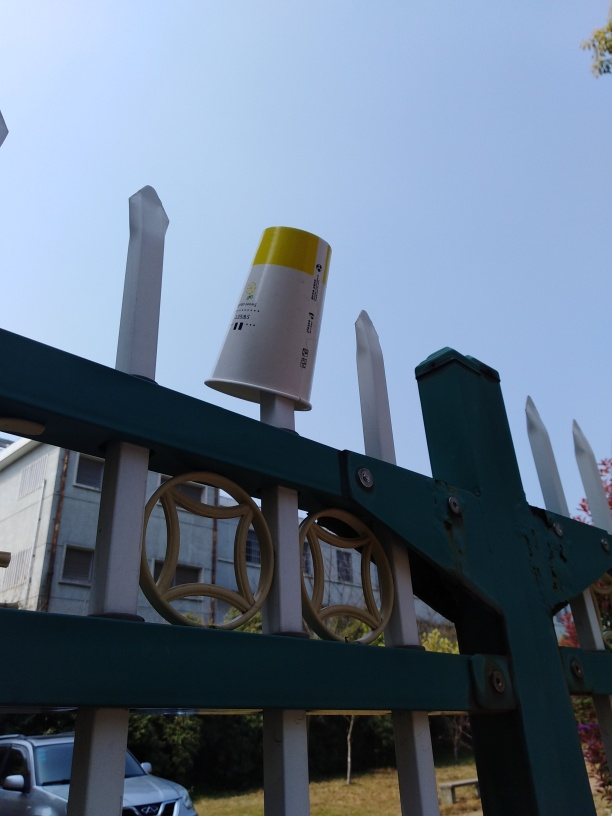Could this image tell us something about the context or location where it was taken? While the image doesn't reveal explicit details about its location, the style of the fence and the architecture visible in the distance suggest a suburban or semi-urban setting. The weather is clear and sunny, indicating a nice day, possibly in a temperate climate. Such clues, like the design of the fencing and the foliage type, can hint at a specific region or neighborhood's character. The presence of the plastic cup might be indicative of local social behavior regarding littering and public space use. 